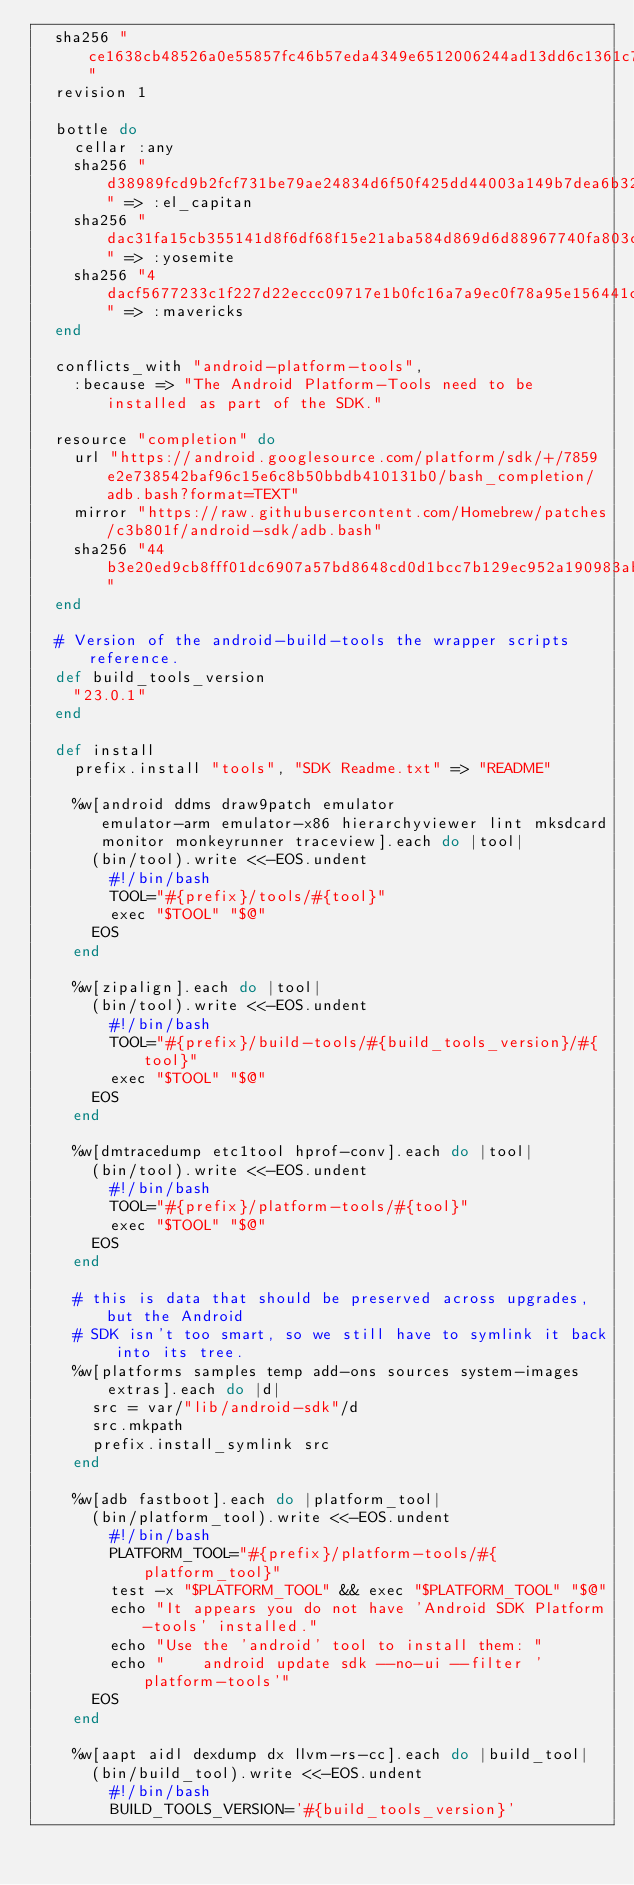Convert code to text. <code><loc_0><loc_0><loc_500><loc_500><_Ruby_>  sha256 "ce1638cb48526a0e55857fc46b57eda4349e6512006244ad13dd6c1361c74104"
  revision 1

  bottle do
    cellar :any
    sha256 "d38989fcd9b2fcf731be79ae24834d6f50f425dd44003a149b7dea6b323a4718" => :el_capitan
    sha256 "dac31fa15cb355141d8f6df68f15e21aba584d869d6d88967740fa803c191464" => :yosemite
    sha256 "4dacf5677233c1f227d22eccc09717e1b0fc16a7a9ec0f78a95e156441c459d7" => :mavericks
  end

  conflicts_with "android-platform-tools",
    :because => "The Android Platform-Tools need to be installed as part of the SDK."

  resource "completion" do
    url "https://android.googlesource.com/platform/sdk/+/7859e2e738542baf96c15e6c8b50bbdb410131b0/bash_completion/adb.bash?format=TEXT"
    mirror "https://raw.githubusercontent.com/Homebrew/patches/c3b801f/android-sdk/adb.bash"
    sha256 "44b3e20ed9cb8fff01dc6907a57bd8648cd0d1bcc7b129ec952a190983ab5e1a"
  end

  # Version of the android-build-tools the wrapper scripts reference.
  def build_tools_version
    "23.0.1"
  end

  def install
    prefix.install "tools", "SDK Readme.txt" => "README"

    %w[android ddms draw9patch emulator
       emulator-arm emulator-x86 hierarchyviewer lint mksdcard
       monitor monkeyrunner traceview].each do |tool|
      (bin/tool).write <<-EOS.undent
        #!/bin/bash
        TOOL="#{prefix}/tools/#{tool}"
        exec "$TOOL" "$@"
      EOS
    end

    %w[zipalign].each do |tool|
      (bin/tool).write <<-EOS.undent
        #!/bin/bash
        TOOL="#{prefix}/build-tools/#{build_tools_version}/#{tool}"
        exec "$TOOL" "$@"
      EOS
    end

    %w[dmtracedump etc1tool hprof-conv].each do |tool|
      (bin/tool).write <<-EOS.undent
        #!/bin/bash
        TOOL="#{prefix}/platform-tools/#{tool}"
        exec "$TOOL" "$@"
      EOS
    end

    # this is data that should be preserved across upgrades, but the Android
    # SDK isn't too smart, so we still have to symlink it back into its tree.
    %w[platforms samples temp add-ons sources system-images extras].each do |d|
      src = var/"lib/android-sdk"/d
      src.mkpath
      prefix.install_symlink src
    end

    %w[adb fastboot].each do |platform_tool|
      (bin/platform_tool).write <<-EOS.undent
        #!/bin/bash
        PLATFORM_TOOL="#{prefix}/platform-tools/#{platform_tool}"
        test -x "$PLATFORM_TOOL" && exec "$PLATFORM_TOOL" "$@"
        echo "It appears you do not have 'Android SDK Platform-tools' installed."
        echo "Use the 'android' tool to install them: "
        echo "    android update sdk --no-ui --filter 'platform-tools'"
      EOS
    end

    %w[aapt aidl dexdump dx llvm-rs-cc].each do |build_tool|
      (bin/build_tool).write <<-EOS.undent
        #!/bin/bash
        BUILD_TOOLS_VERSION='#{build_tools_version}'</code> 